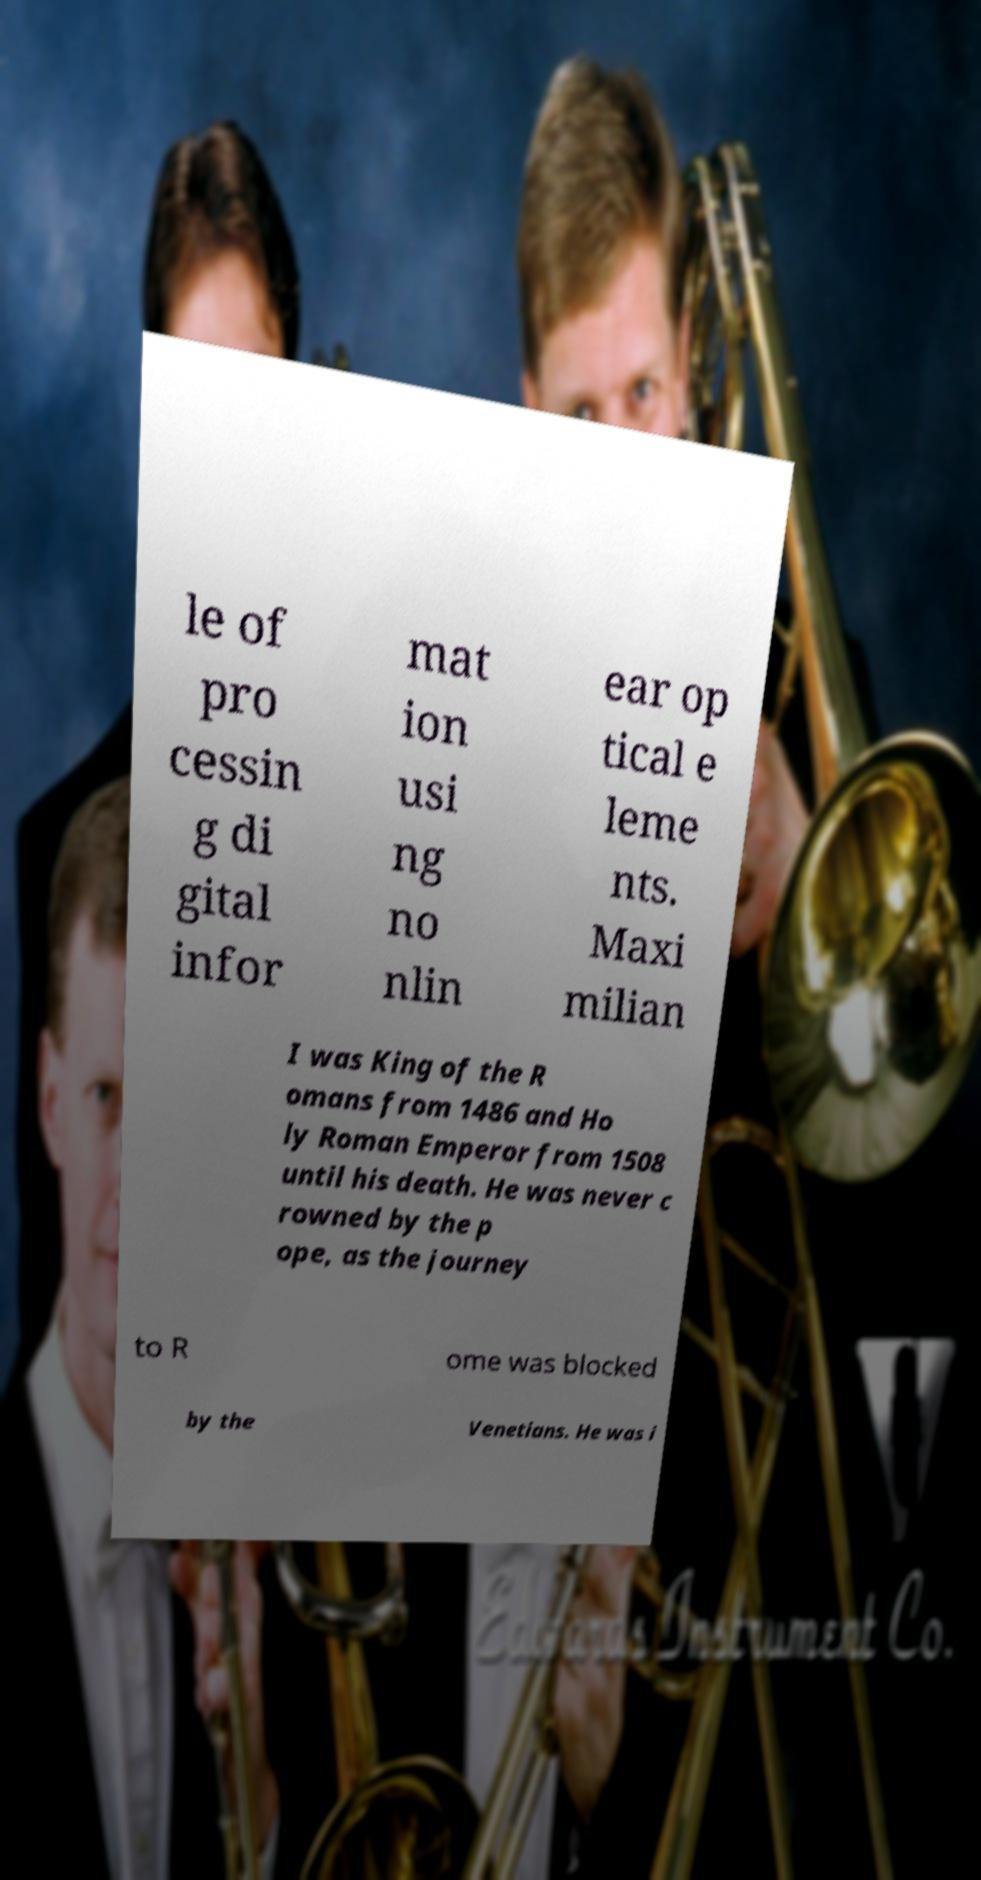Can you accurately transcribe the text from the provided image for me? le of pro cessin g di gital infor mat ion usi ng no nlin ear op tical e leme nts. Maxi milian I was King of the R omans from 1486 and Ho ly Roman Emperor from 1508 until his death. He was never c rowned by the p ope, as the journey to R ome was blocked by the Venetians. He was i 